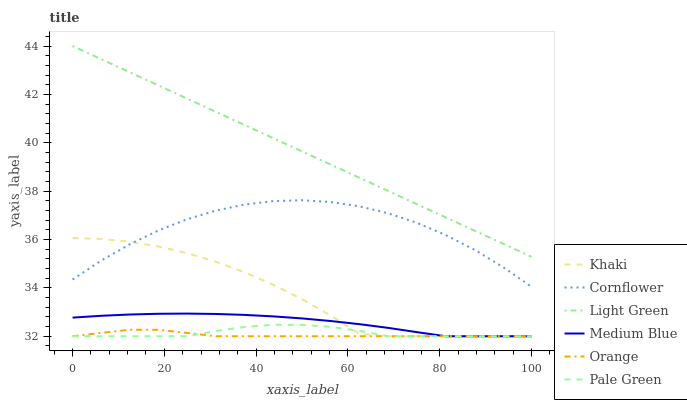Does Khaki have the minimum area under the curve?
Answer yes or no. No. Does Khaki have the maximum area under the curve?
Answer yes or no. No. Is Khaki the smoothest?
Answer yes or no. No. Is Khaki the roughest?
Answer yes or no. No. Does Light Green have the lowest value?
Answer yes or no. No. Does Khaki have the highest value?
Answer yes or no. No. Is Khaki less than Light Green?
Answer yes or no. Yes. Is Light Green greater than Cornflower?
Answer yes or no. Yes. Does Khaki intersect Light Green?
Answer yes or no. No. 